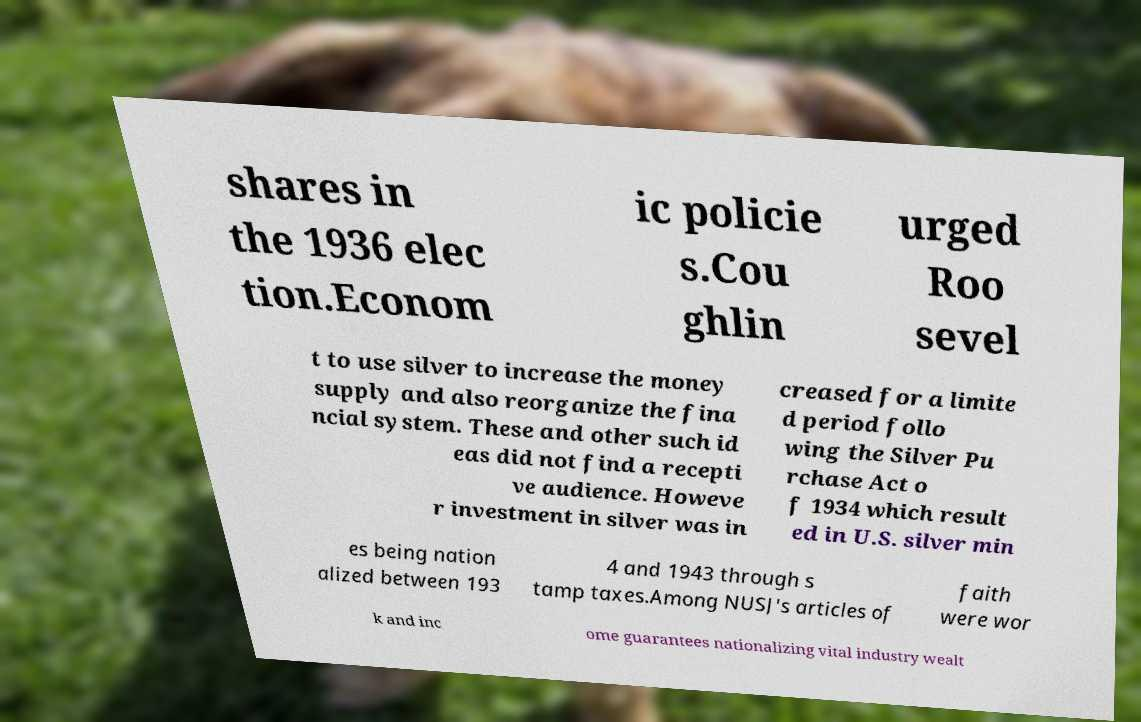What messages or text are displayed in this image? I need them in a readable, typed format. shares in the 1936 elec tion.Econom ic policie s.Cou ghlin urged Roo sevel t to use silver to increase the money supply and also reorganize the fina ncial system. These and other such id eas did not find a recepti ve audience. Howeve r investment in silver was in creased for a limite d period follo wing the Silver Pu rchase Act o f 1934 which result ed in U.S. silver min es being nation alized between 193 4 and 1943 through s tamp taxes.Among NUSJ's articles of faith were wor k and inc ome guarantees nationalizing vital industry wealt 